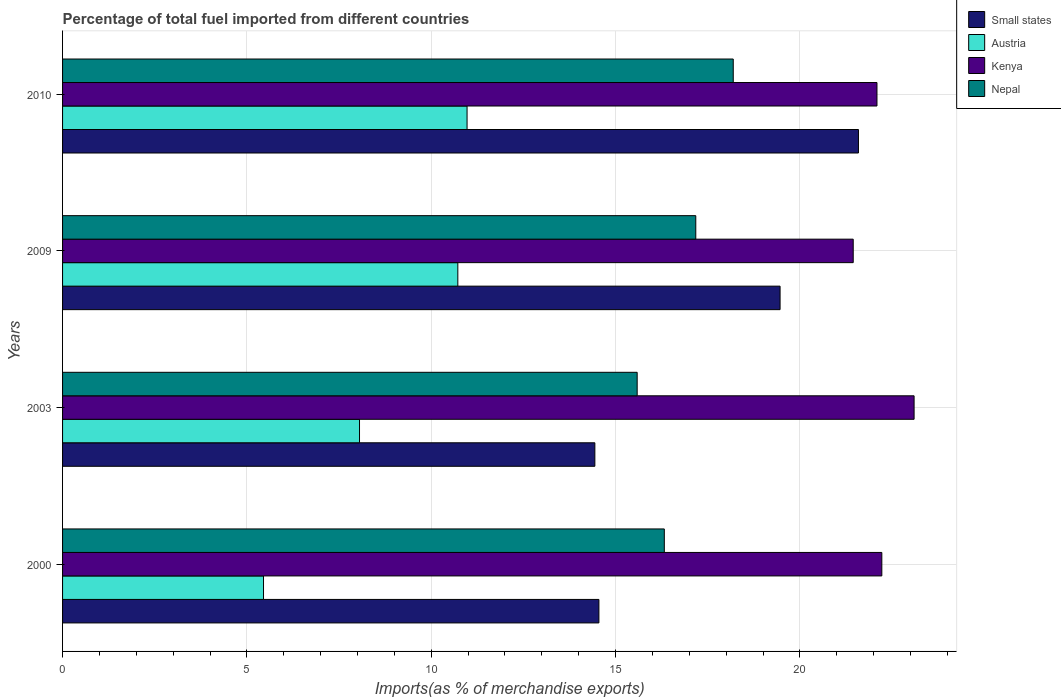How many groups of bars are there?
Your answer should be very brief. 4. Are the number of bars per tick equal to the number of legend labels?
Your answer should be compact. Yes. How many bars are there on the 4th tick from the top?
Your response must be concise. 4. How many bars are there on the 4th tick from the bottom?
Offer a very short reply. 4. What is the label of the 3rd group of bars from the top?
Offer a terse response. 2003. In how many cases, is the number of bars for a given year not equal to the number of legend labels?
Keep it short and to the point. 0. What is the percentage of imports to different countries in Small states in 2003?
Your answer should be compact. 14.44. Across all years, what is the maximum percentage of imports to different countries in Small states?
Offer a terse response. 21.59. Across all years, what is the minimum percentage of imports to different countries in Nepal?
Your answer should be very brief. 15.59. What is the total percentage of imports to different countries in Kenya in the graph?
Make the answer very short. 88.85. What is the difference between the percentage of imports to different countries in Small states in 2000 and that in 2009?
Keep it short and to the point. -4.91. What is the difference between the percentage of imports to different countries in Kenya in 2010 and the percentage of imports to different countries in Small states in 2009?
Offer a terse response. 2.63. What is the average percentage of imports to different countries in Austria per year?
Offer a very short reply. 8.8. In the year 2009, what is the difference between the percentage of imports to different countries in Austria and percentage of imports to different countries in Kenya?
Ensure brevity in your answer.  -10.72. In how many years, is the percentage of imports to different countries in Kenya greater than 13 %?
Provide a short and direct response. 4. What is the ratio of the percentage of imports to different countries in Nepal in 2003 to that in 2010?
Give a very brief answer. 0.86. What is the difference between the highest and the second highest percentage of imports to different countries in Austria?
Offer a very short reply. 0.25. What is the difference between the highest and the lowest percentage of imports to different countries in Kenya?
Offer a very short reply. 1.65. Is the sum of the percentage of imports to different countries in Small states in 2000 and 2009 greater than the maximum percentage of imports to different countries in Nepal across all years?
Ensure brevity in your answer.  Yes. Is it the case that in every year, the sum of the percentage of imports to different countries in Austria and percentage of imports to different countries in Kenya is greater than the sum of percentage of imports to different countries in Nepal and percentage of imports to different countries in Small states?
Provide a short and direct response. No. What does the 2nd bar from the top in 2010 represents?
Ensure brevity in your answer.  Kenya. What does the 4th bar from the bottom in 2003 represents?
Give a very brief answer. Nepal. Are all the bars in the graph horizontal?
Your answer should be very brief. Yes. How many years are there in the graph?
Your answer should be compact. 4. Does the graph contain grids?
Offer a terse response. Yes. How are the legend labels stacked?
Provide a short and direct response. Vertical. What is the title of the graph?
Offer a very short reply. Percentage of total fuel imported from different countries. Does "Uruguay" appear as one of the legend labels in the graph?
Your answer should be compact. No. What is the label or title of the X-axis?
Offer a very short reply. Imports(as % of merchandise exports). What is the label or title of the Y-axis?
Your answer should be compact. Years. What is the Imports(as % of merchandise exports) in Small states in 2000?
Give a very brief answer. 14.55. What is the Imports(as % of merchandise exports) of Austria in 2000?
Your answer should be compact. 5.45. What is the Imports(as % of merchandise exports) of Kenya in 2000?
Your answer should be compact. 22.22. What is the Imports(as % of merchandise exports) in Nepal in 2000?
Make the answer very short. 16.32. What is the Imports(as % of merchandise exports) of Small states in 2003?
Make the answer very short. 14.44. What is the Imports(as % of merchandise exports) of Austria in 2003?
Your answer should be very brief. 8.05. What is the Imports(as % of merchandise exports) in Kenya in 2003?
Your answer should be compact. 23.1. What is the Imports(as % of merchandise exports) in Nepal in 2003?
Make the answer very short. 15.59. What is the Imports(as % of merchandise exports) of Small states in 2009?
Give a very brief answer. 19.46. What is the Imports(as % of merchandise exports) in Austria in 2009?
Offer a terse response. 10.72. What is the Imports(as % of merchandise exports) in Kenya in 2009?
Keep it short and to the point. 21.45. What is the Imports(as % of merchandise exports) in Nepal in 2009?
Make the answer very short. 17.17. What is the Imports(as % of merchandise exports) of Small states in 2010?
Make the answer very short. 21.59. What is the Imports(as % of merchandise exports) of Austria in 2010?
Your answer should be compact. 10.97. What is the Imports(as % of merchandise exports) of Kenya in 2010?
Provide a short and direct response. 22.09. What is the Imports(as % of merchandise exports) of Nepal in 2010?
Ensure brevity in your answer.  18.19. Across all years, what is the maximum Imports(as % of merchandise exports) of Small states?
Make the answer very short. 21.59. Across all years, what is the maximum Imports(as % of merchandise exports) in Austria?
Ensure brevity in your answer.  10.97. Across all years, what is the maximum Imports(as % of merchandise exports) of Kenya?
Provide a short and direct response. 23.1. Across all years, what is the maximum Imports(as % of merchandise exports) in Nepal?
Make the answer very short. 18.19. Across all years, what is the minimum Imports(as % of merchandise exports) in Small states?
Make the answer very short. 14.44. Across all years, what is the minimum Imports(as % of merchandise exports) in Austria?
Make the answer very short. 5.45. Across all years, what is the minimum Imports(as % of merchandise exports) in Kenya?
Provide a short and direct response. 21.45. Across all years, what is the minimum Imports(as % of merchandise exports) in Nepal?
Give a very brief answer. 15.59. What is the total Imports(as % of merchandise exports) in Small states in the graph?
Your answer should be compact. 70.03. What is the total Imports(as % of merchandise exports) of Austria in the graph?
Provide a short and direct response. 35.2. What is the total Imports(as % of merchandise exports) in Kenya in the graph?
Provide a succinct answer. 88.85. What is the total Imports(as % of merchandise exports) in Nepal in the graph?
Give a very brief answer. 67.27. What is the difference between the Imports(as % of merchandise exports) in Small states in 2000 and that in 2003?
Your answer should be compact. 0.11. What is the difference between the Imports(as % of merchandise exports) in Austria in 2000 and that in 2003?
Your answer should be compact. -2.6. What is the difference between the Imports(as % of merchandise exports) in Kenya in 2000 and that in 2003?
Your answer should be very brief. -0.88. What is the difference between the Imports(as % of merchandise exports) of Nepal in 2000 and that in 2003?
Offer a terse response. 0.74. What is the difference between the Imports(as % of merchandise exports) in Small states in 2000 and that in 2009?
Provide a succinct answer. -4.91. What is the difference between the Imports(as % of merchandise exports) of Austria in 2000 and that in 2009?
Give a very brief answer. -5.27. What is the difference between the Imports(as % of merchandise exports) of Kenya in 2000 and that in 2009?
Give a very brief answer. 0.78. What is the difference between the Imports(as % of merchandise exports) in Nepal in 2000 and that in 2009?
Provide a short and direct response. -0.85. What is the difference between the Imports(as % of merchandise exports) in Small states in 2000 and that in 2010?
Give a very brief answer. -7.04. What is the difference between the Imports(as % of merchandise exports) of Austria in 2000 and that in 2010?
Offer a very short reply. -5.52. What is the difference between the Imports(as % of merchandise exports) of Kenya in 2000 and that in 2010?
Offer a very short reply. 0.13. What is the difference between the Imports(as % of merchandise exports) in Nepal in 2000 and that in 2010?
Offer a terse response. -1.87. What is the difference between the Imports(as % of merchandise exports) in Small states in 2003 and that in 2009?
Ensure brevity in your answer.  -5.02. What is the difference between the Imports(as % of merchandise exports) of Austria in 2003 and that in 2009?
Keep it short and to the point. -2.67. What is the difference between the Imports(as % of merchandise exports) of Kenya in 2003 and that in 2009?
Provide a succinct answer. 1.65. What is the difference between the Imports(as % of merchandise exports) in Nepal in 2003 and that in 2009?
Your response must be concise. -1.59. What is the difference between the Imports(as % of merchandise exports) of Small states in 2003 and that in 2010?
Offer a terse response. -7.15. What is the difference between the Imports(as % of merchandise exports) in Austria in 2003 and that in 2010?
Ensure brevity in your answer.  -2.92. What is the difference between the Imports(as % of merchandise exports) of Kenya in 2003 and that in 2010?
Make the answer very short. 1.01. What is the difference between the Imports(as % of merchandise exports) of Nepal in 2003 and that in 2010?
Your response must be concise. -2.61. What is the difference between the Imports(as % of merchandise exports) in Small states in 2009 and that in 2010?
Provide a short and direct response. -2.13. What is the difference between the Imports(as % of merchandise exports) of Austria in 2009 and that in 2010?
Provide a short and direct response. -0.25. What is the difference between the Imports(as % of merchandise exports) of Kenya in 2009 and that in 2010?
Keep it short and to the point. -0.64. What is the difference between the Imports(as % of merchandise exports) of Nepal in 2009 and that in 2010?
Provide a short and direct response. -1.02. What is the difference between the Imports(as % of merchandise exports) of Small states in 2000 and the Imports(as % of merchandise exports) of Austria in 2003?
Give a very brief answer. 6.49. What is the difference between the Imports(as % of merchandise exports) in Small states in 2000 and the Imports(as % of merchandise exports) in Kenya in 2003?
Provide a short and direct response. -8.55. What is the difference between the Imports(as % of merchandise exports) of Small states in 2000 and the Imports(as % of merchandise exports) of Nepal in 2003?
Provide a succinct answer. -1.04. What is the difference between the Imports(as % of merchandise exports) of Austria in 2000 and the Imports(as % of merchandise exports) of Kenya in 2003?
Provide a succinct answer. -17.65. What is the difference between the Imports(as % of merchandise exports) of Austria in 2000 and the Imports(as % of merchandise exports) of Nepal in 2003?
Give a very brief answer. -10.13. What is the difference between the Imports(as % of merchandise exports) in Kenya in 2000 and the Imports(as % of merchandise exports) in Nepal in 2003?
Provide a short and direct response. 6.64. What is the difference between the Imports(as % of merchandise exports) in Small states in 2000 and the Imports(as % of merchandise exports) in Austria in 2009?
Give a very brief answer. 3.83. What is the difference between the Imports(as % of merchandise exports) in Small states in 2000 and the Imports(as % of merchandise exports) in Kenya in 2009?
Your answer should be very brief. -6.9. What is the difference between the Imports(as % of merchandise exports) in Small states in 2000 and the Imports(as % of merchandise exports) in Nepal in 2009?
Provide a short and direct response. -2.63. What is the difference between the Imports(as % of merchandise exports) in Austria in 2000 and the Imports(as % of merchandise exports) in Kenya in 2009?
Offer a terse response. -15.99. What is the difference between the Imports(as % of merchandise exports) of Austria in 2000 and the Imports(as % of merchandise exports) of Nepal in 2009?
Provide a short and direct response. -11.72. What is the difference between the Imports(as % of merchandise exports) of Kenya in 2000 and the Imports(as % of merchandise exports) of Nepal in 2009?
Offer a terse response. 5.05. What is the difference between the Imports(as % of merchandise exports) in Small states in 2000 and the Imports(as % of merchandise exports) in Austria in 2010?
Give a very brief answer. 3.58. What is the difference between the Imports(as % of merchandise exports) of Small states in 2000 and the Imports(as % of merchandise exports) of Kenya in 2010?
Make the answer very short. -7.54. What is the difference between the Imports(as % of merchandise exports) in Small states in 2000 and the Imports(as % of merchandise exports) in Nepal in 2010?
Offer a terse response. -3.64. What is the difference between the Imports(as % of merchandise exports) in Austria in 2000 and the Imports(as % of merchandise exports) in Kenya in 2010?
Offer a very short reply. -16.64. What is the difference between the Imports(as % of merchandise exports) of Austria in 2000 and the Imports(as % of merchandise exports) of Nepal in 2010?
Provide a short and direct response. -12.74. What is the difference between the Imports(as % of merchandise exports) of Kenya in 2000 and the Imports(as % of merchandise exports) of Nepal in 2010?
Make the answer very short. 4.03. What is the difference between the Imports(as % of merchandise exports) of Small states in 2003 and the Imports(as % of merchandise exports) of Austria in 2009?
Your answer should be very brief. 3.72. What is the difference between the Imports(as % of merchandise exports) of Small states in 2003 and the Imports(as % of merchandise exports) of Kenya in 2009?
Provide a short and direct response. -7.01. What is the difference between the Imports(as % of merchandise exports) of Small states in 2003 and the Imports(as % of merchandise exports) of Nepal in 2009?
Provide a short and direct response. -2.74. What is the difference between the Imports(as % of merchandise exports) in Austria in 2003 and the Imports(as % of merchandise exports) in Kenya in 2009?
Ensure brevity in your answer.  -13.39. What is the difference between the Imports(as % of merchandise exports) of Austria in 2003 and the Imports(as % of merchandise exports) of Nepal in 2009?
Your response must be concise. -9.12. What is the difference between the Imports(as % of merchandise exports) of Kenya in 2003 and the Imports(as % of merchandise exports) of Nepal in 2009?
Provide a succinct answer. 5.92. What is the difference between the Imports(as % of merchandise exports) in Small states in 2003 and the Imports(as % of merchandise exports) in Austria in 2010?
Provide a succinct answer. 3.47. What is the difference between the Imports(as % of merchandise exports) of Small states in 2003 and the Imports(as % of merchandise exports) of Kenya in 2010?
Give a very brief answer. -7.65. What is the difference between the Imports(as % of merchandise exports) in Small states in 2003 and the Imports(as % of merchandise exports) in Nepal in 2010?
Provide a short and direct response. -3.75. What is the difference between the Imports(as % of merchandise exports) in Austria in 2003 and the Imports(as % of merchandise exports) in Kenya in 2010?
Offer a very short reply. -14.04. What is the difference between the Imports(as % of merchandise exports) of Austria in 2003 and the Imports(as % of merchandise exports) of Nepal in 2010?
Provide a short and direct response. -10.14. What is the difference between the Imports(as % of merchandise exports) in Kenya in 2003 and the Imports(as % of merchandise exports) in Nepal in 2010?
Provide a short and direct response. 4.91. What is the difference between the Imports(as % of merchandise exports) of Small states in 2009 and the Imports(as % of merchandise exports) of Austria in 2010?
Provide a succinct answer. 8.49. What is the difference between the Imports(as % of merchandise exports) in Small states in 2009 and the Imports(as % of merchandise exports) in Kenya in 2010?
Make the answer very short. -2.63. What is the difference between the Imports(as % of merchandise exports) in Small states in 2009 and the Imports(as % of merchandise exports) in Nepal in 2010?
Offer a very short reply. 1.27. What is the difference between the Imports(as % of merchandise exports) of Austria in 2009 and the Imports(as % of merchandise exports) of Kenya in 2010?
Offer a terse response. -11.37. What is the difference between the Imports(as % of merchandise exports) of Austria in 2009 and the Imports(as % of merchandise exports) of Nepal in 2010?
Provide a succinct answer. -7.47. What is the difference between the Imports(as % of merchandise exports) of Kenya in 2009 and the Imports(as % of merchandise exports) of Nepal in 2010?
Your answer should be very brief. 3.25. What is the average Imports(as % of merchandise exports) of Small states per year?
Provide a short and direct response. 17.51. What is the average Imports(as % of merchandise exports) in Austria per year?
Your answer should be compact. 8.8. What is the average Imports(as % of merchandise exports) in Kenya per year?
Ensure brevity in your answer.  22.21. What is the average Imports(as % of merchandise exports) of Nepal per year?
Give a very brief answer. 16.82. In the year 2000, what is the difference between the Imports(as % of merchandise exports) of Small states and Imports(as % of merchandise exports) of Austria?
Make the answer very short. 9.1. In the year 2000, what is the difference between the Imports(as % of merchandise exports) of Small states and Imports(as % of merchandise exports) of Kenya?
Provide a succinct answer. -7.67. In the year 2000, what is the difference between the Imports(as % of merchandise exports) of Small states and Imports(as % of merchandise exports) of Nepal?
Keep it short and to the point. -1.77. In the year 2000, what is the difference between the Imports(as % of merchandise exports) of Austria and Imports(as % of merchandise exports) of Kenya?
Your answer should be very brief. -16.77. In the year 2000, what is the difference between the Imports(as % of merchandise exports) of Austria and Imports(as % of merchandise exports) of Nepal?
Ensure brevity in your answer.  -10.87. In the year 2000, what is the difference between the Imports(as % of merchandise exports) in Kenya and Imports(as % of merchandise exports) in Nepal?
Your response must be concise. 5.9. In the year 2003, what is the difference between the Imports(as % of merchandise exports) in Small states and Imports(as % of merchandise exports) in Austria?
Your response must be concise. 6.38. In the year 2003, what is the difference between the Imports(as % of merchandise exports) of Small states and Imports(as % of merchandise exports) of Kenya?
Your answer should be very brief. -8.66. In the year 2003, what is the difference between the Imports(as % of merchandise exports) of Small states and Imports(as % of merchandise exports) of Nepal?
Provide a short and direct response. -1.15. In the year 2003, what is the difference between the Imports(as % of merchandise exports) of Austria and Imports(as % of merchandise exports) of Kenya?
Provide a short and direct response. -15.04. In the year 2003, what is the difference between the Imports(as % of merchandise exports) of Austria and Imports(as % of merchandise exports) of Nepal?
Offer a very short reply. -7.53. In the year 2003, what is the difference between the Imports(as % of merchandise exports) in Kenya and Imports(as % of merchandise exports) in Nepal?
Provide a succinct answer. 7.51. In the year 2009, what is the difference between the Imports(as % of merchandise exports) of Small states and Imports(as % of merchandise exports) of Austria?
Your answer should be compact. 8.74. In the year 2009, what is the difference between the Imports(as % of merchandise exports) of Small states and Imports(as % of merchandise exports) of Kenya?
Your answer should be very brief. -1.98. In the year 2009, what is the difference between the Imports(as % of merchandise exports) in Small states and Imports(as % of merchandise exports) in Nepal?
Make the answer very short. 2.29. In the year 2009, what is the difference between the Imports(as % of merchandise exports) in Austria and Imports(as % of merchandise exports) in Kenya?
Offer a very short reply. -10.72. In the year 2009, what is the difference between the Imports(as % of merchandise exports) of Austria and Imports(as % of merchandise exports) of Nepal?
Offer a very short reply. -6.45. In the year 2009, what is the difference between the Imports(as % of merchandise exports) in Kenya and Imports(as % of merchandise exports) in Nepal?
Offer a terse response. 4.27. In the year 2010, what is the difference between the Imports(as % of merchandise exports) of Small states and Imports(as % of merchandise exports) of Austria?
Offer a terse response. 10.62. In the year 2010, what is the difference between the Imports(as % of merchandise exports) of Small states and Imports(as % of merchandise exports) of Kenya?
Provide a short and direct response. -0.5. In the year 2010, what is the difference between the Imports(as % of merchandise exports) of Small states and Imports(as % of merchandise exports) of Nepal?
Make the answer very short. 3.4. In the year 2010, what is the difference between the Imports(as % of merchandise exports) of Austria and Imports(as % of merchandise exports) of Kenya?
Offer a very short reply. -11.12. In the year 2010, what is the difference between the Imports(as % of merchandise exports) of Austria and Imports(as % of merchandise exports) of Nepal?
Give a very brief answer. -7.22. In the year 2010, what is the difference between the Imports(as % of merchandise exports) in Kenya and Imports(as % of merchandise exports) in Nepal?
Provide a short and direct response. 3.9. What is the ratio of the Imports(as % of merchandise exports) in Small states in 2000 to that in 2003?
Your response must be concise. 1.01. What is the ratio of the Imports(as % of merchandise exports) in Austria in 2000 to that in 2003?
Provide a succinct answer. 0.68. What is the ratio of the Imports(as % of merchandise exports) of Kenya in 2000 to that in 2003?
Offer a terse response. 0.96. What is the ratio of the Imports(as % of merchandise exports) of Nepal in 2000 to that in 2003?
Your answer should be very brief. 1.05. What is the ratio of the Imports(as % of merchandise exports) of Small states in 2000 to that in 2009?
Provide a succinct answer. 0.75. What is the ratio of the Imports(as % of merchandise exports) of Austria in 2000 to that in 2009?
Your answer should be compact. 0.51. What is the ratio of the Imports(as % of merchandise exports) of Kenya in 2000 to that in 2009?
Ensure brevity in your answer.  1.04. What is the ratio of the Imports(as % of merchandise exports) in Nepal in 2000 to that in 2009?
Provide a succinct answer. 0.95. What is the ratio of the Imports(as % of merchandise exports) in Small states in 2000 to that in 2010?
Make the answer very short. 0.67. What is the ratio of the Imports(as % of merchandise exports) of Austria in 2000 to that in 2010?
Your answer should be compact. 0.5. What is the ratio of the Imports(as % of merchandise exports) in Nepal in 2000 to that in 2010?
Give a very brief answer. 0.9. What is the ratio of the Imports(as % of merchandise exports) in Small states in 2003 to that in 2009?
Provide a short and direct response. 0.74. What is the ratio of the Imports(as % of merchandise exports) of Austria in 2003 to that in 2009?
Your answer should be very brief. 0.75. What is the ratio of the Imports(as % of merchandise exports) of Kenya in 2003 to that in 2009?
Your response must be concise. 1.08. What is the ratio of the Imports(as % of merchandise exports) in Nepal in 2003 to that in 2009?
Your answer should be compact. 0.91. What is the ratio of the Imports(as % of merchandise exports) of Small states in 2003 to that in 2010?
Your response must be concise. 0.67. What is the ratio of the Imports(as % of merchandise exports) of Austria in 2003 to that in 2010?
Provide a short and direct response. 0.73. What is the ratio of the Imports(as % of merchandise exports) in Kenya in 2003 to that in 2010?
Provide a succinct answer. 1.05. What is the ratio of the Imports(as % of merchandise exports) of Nepal in 2003 to that in 2010?
Make the answer very short. 0.86. What is the ratio of the Imports(as % of merchandise exports) of Small states in 2009 to that in 2010?
Your response must be concise. 0.9. What is the ratio of the Imports(as % of merchandise exports) in Austria in 2009 to that in 2010?
Offer a very short reply. 0.98. What is the ratio of the Imports(as % of merchandise exports) of Kenya in 2009 to that in 2010?
Provide a short and direct response. 0.97. What is the ratio of the Imports(as % of merchandise exports) of Nepal in 2009 to that in 2010?
Offer a terse response. 0.94. What is the difference between the highest and the second highest Imports(as % of merchandise exports) of Small states?
Give a very brief answer. 2.13. What is the difference between the highest and the second highest Imports(as % of merchandise exports) of Austria?
Provide a succinct answer. 0.25. What is the difference between the highest and the second highest Imports(as % of merchandise exports) in Kenya?
Make the answer very short. 0.88. What is the difference between the highest and the second highest Imports(as % of merchandise exports) in Nepal?
Provide a short and direct response. 1.02. What is the difference between the highest and the lowest Imports(as % of merchandise exports) in Small states?
Provide a short and direct response. 7.15. What is the difference between the highest and the lowest Imports(as % of merchandise exports) of Austria?
Ensure brevity in your answer.  5.52. What is the difference between the highest and the lowest Imports(as % of merchandise exports) of Kenya?
Provide a short and direct response. 1.65. What is the difference between the highest and the lowest Imports(as % of merchandise exports) of Nepal?
Ensure brevity in your answer.  2.61. 